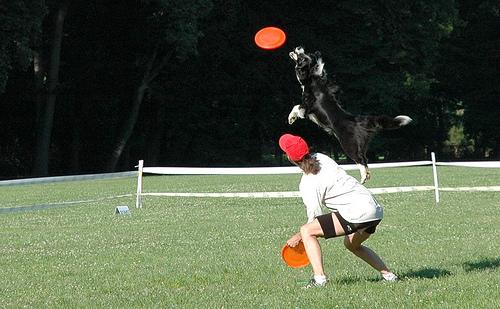How many bright colored items are in the photo?
Concise answer only. 3. Was this dog trained?
Keep it brief. Yes. What color is the frisbee?
Give a very brief answer. Orange. 